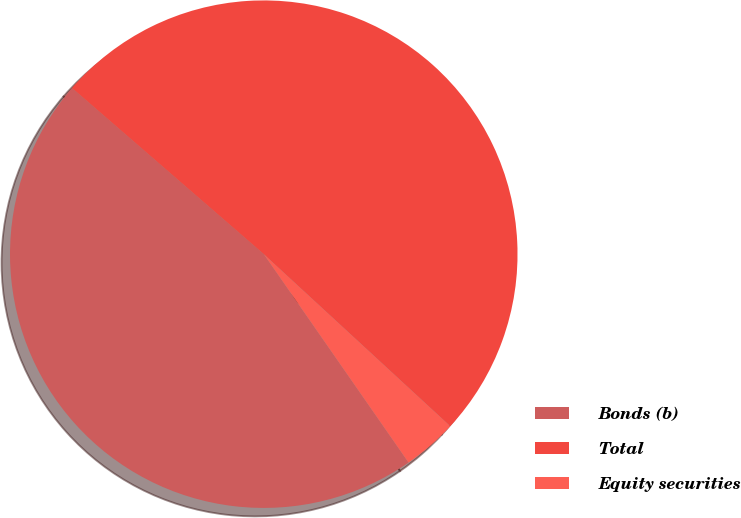Convert chart to OTSL. <chart><loc_0><loc_0><loc_500><loc_500><pie_chart><fcel>Bonds (b)<fcel>Total<fcel>Equity securities<nl><fcel>46.03%<fcel>50.5%<fcel>3.48%<nl></chart> 